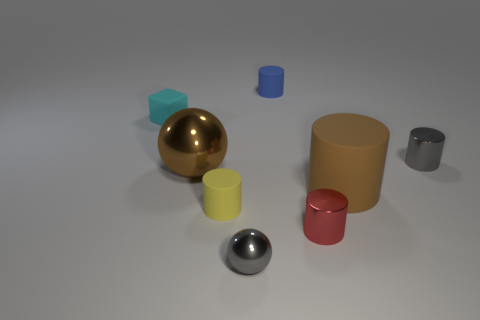Is there anything else that is the same shape as the cyan object?
Keep it short and to the point. No. Is there a small matte block?
Provide a succinct answer. Yes. Is the number of objects that are behind the small gray shiny ball greater than the number of small objects that are left of the tiny blue cylinder?
Ensure brevity in your answer.  Yes. What is the size of the yellow cylinder that is the same material as the cyan cube?
Provide a succinct answer. Small. There is a yellow cylinder in front of the tiny matte thing that is to the right of the cylinder that is left of the tiny blue thing; what is its size?
Provide a succinct answer. Small. What is the color of the small matte object in front of the gray cylinder?
Provide a succinct answer. Yellow. Are there more tiny gray things that are in front of the small gray cylinder than gray rubber cubes?
Your answer should be compact. Yes. There is a gray shiny thing that is in front of the big cylinder; does it have the same shape as the brown shiny thing?
Offer a terse response. Yes. What number of brown things are large matte cylinders or rubber cubes?
Offer a terse response. 1. Is the number of brown metal blocks greater than the number of small gray balls?
Give a very brief answer. No. 